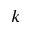Convert formula to latex. <formula><loc_0><loc_0><loc_500><loc_500>k</formula> 